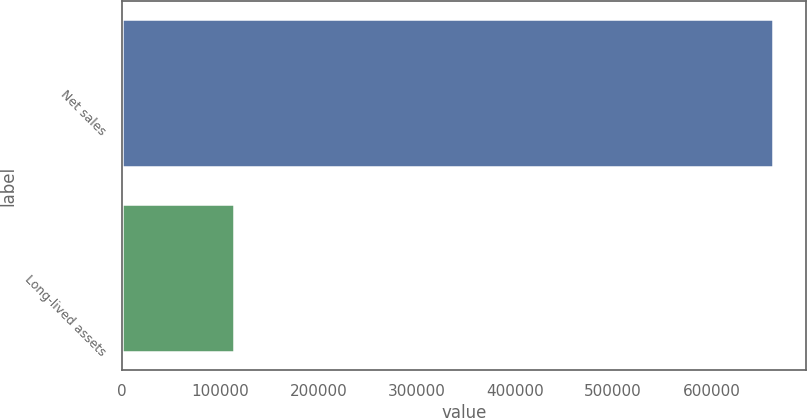Convert chart. <chart><loc_0><loc_0><loc_500><loc_500><bar_chart><fcel>Net sales<fcel>Long-lived assets<nl><fcel>663054<fcel>114593<nl></chart> 